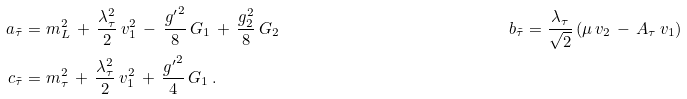Convert formula to latex. <formula><loc_0><loc_0><loc_500><loc_500>a _ { \tilde { \tau } } & = m _ { L } ^ { 2 } \, + \, \frac { \lambda _ { \tau } ^ { 2 } } { 2 } \, v _ { 1 } ^ { 2 } \, - \, \frac { { g ^ { \prime } } ^ { 2 } } { 8 } \, G _ { 1 } \, + \, \frac { g _ { 2 } ^ { 2 } } { 8 } \, G _ { 2 } & b _ { \tilde { \tau } } & = \frac { \lambda _ { \tau } } { \sqrt { 2 } } \, ( \mu \, v _ { 2 } \, - \, A _ { \tau } \, v _ { 1 } ) \\ c _ { \tilde { \tau } } & = m _ { \tau } ^ { 2 } \, + \, \frac { \lambda _ { \tau } ^ { 2 } } { 2 } \, v _ { 1 } ^ { 2 } \, + \, \frac { { g ^ { \prime } } ^ { 2 } } { 4 } \, G _ { 1 } \, . & &</formula> 